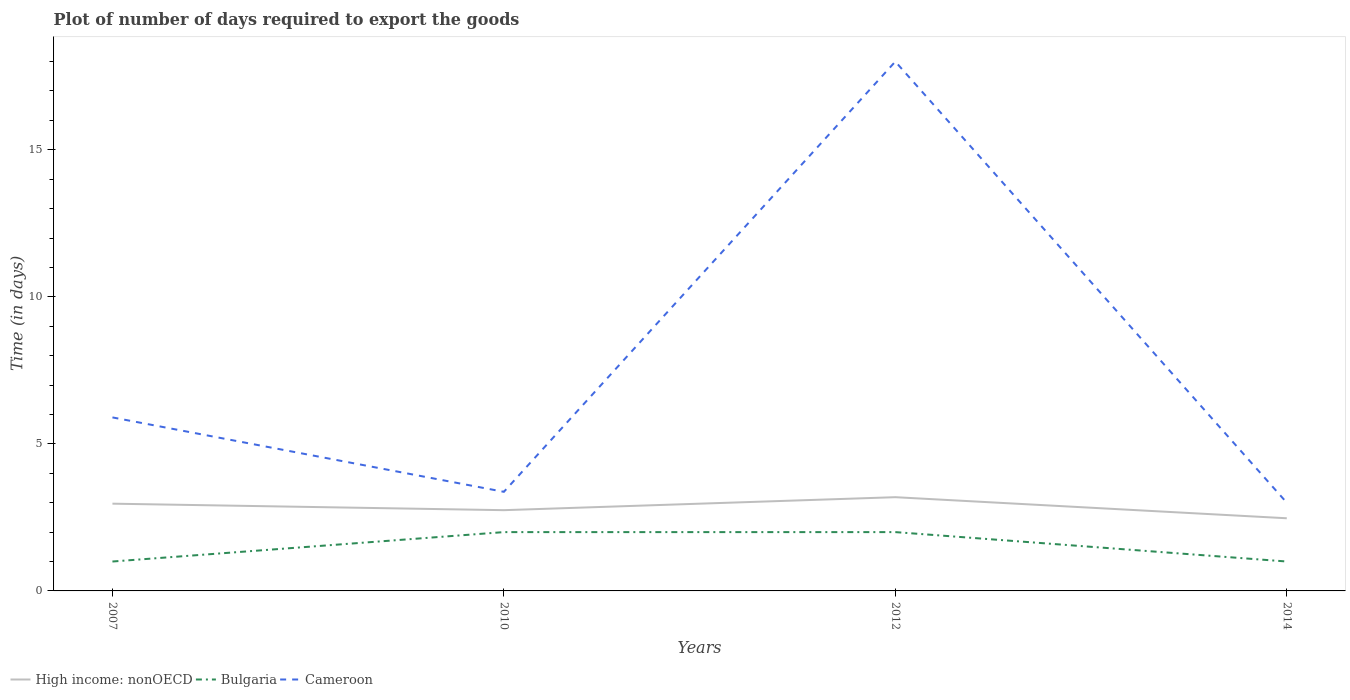How many different coloured lines are there?
Provide a succinct answer. 3. Does the line corresponding to Cameroon intersect with the line corresponding to Bulgaria?
Provide a succinct answer. No. Is the number of lines equal to the number of legend labels?
Give a very brief answer. Yes. In which year was the time required to export goods in Cameroon maximum?
Your response must be concise. 2014. What is the total time required to export goods in High income: nonOECD in the graph?
Give a very brief answer. -0.44. What is the difference between the highest and the second highest time required to export goods in Bulgaria?
Offer a terse response. 1. What is the difference between the highest and the lowest time required to export goods in High income: nonOECD?
Your response must be concise. 2. Is the time required to export goods in High income: nonOECD strictly greater than the time required to export goods in Cameroon over the years?
Provide a succinct answer. Yes. Are the values on the major ticks of Y-axis written in scientific E-notation?
Your answer should be very brief. No. Where does the legend appear in the graph?
Give a very brief answer. Bottom left. What is the title of the graph?
Provide a short and direct response. Plot of number of days required to export the goods. What is the label or title of the Y-axis?
Keep it short and to the point. Time (in days). What is the Time (in days) in High income: nonOECD in 2007?
Make the answer very short. 2.97. What is the Time (in days) of High income: nonOECD in 2010?
Your answer should be very brief. 2.75. What is the Time (in days) of Cameroon in 2010?
Give a very brief answer. 3.37. What is the Time (in days) in High income: nonOECD in 2012?
Give a very brief answer. 3.19. What is the Time (in days) of Bulgaria in 2012?
Give a very brief answer. 2. What is the Time (in days) of Cameroon in 2012?
Keep it short and to the point. 18. What is the Time (in days) in High income: nonOECD in 2014?
Keep it short and to the point. 2.47. Across all years, what is the maximum Time (in days) of High income: nonOECD?
Provide a short and direct response. 3.19. Across all years, what is the maximum Time (in days) of Bulgaria?
Your answer should be compact. 2. Across all years, what is the maximum Time (in days) in Cameroon?
Offer a very short reply. 18. Across all years, what is the minimum Time (in days) of High income: nonOECD?
Offer a terse response. 2.47. Across all years, what is the minimum Time (in days) of Bulgaria?
Your response must be concise. 1. Across all years, what is the minimum Time (in days) in Cameroon?
Make the answer very short. 3. What is the total Time (in days) in High income: nonOECD in the graph?
Your answer should be very brief. 11.37. What is the total Time (in days) of Bulgaria in the graph?
Your answer should be compact. 6. What is the total Time (in days) in Cameroon in the graph?
Your response must be concise. 30.27. What is the difference between the Time (in days) in High income: nonOECD in 2007 and that in 2010?
Offer a very short reply. 0.22. What is the difference between the Time (in days) of Bulgaria in 2007 and that in 2010?
Your answer should be compact. -1. What is the difference between the Time (in days) of Cameroon in 2007 and that in 2010?
Your answer should be very brief. 2.53. What is the difference between the Time (in days) in High income: nonOECD in 2007 and that in 2012?
Keep it short and to the point. -0.22. What is the difference between the Time (in days) in Bulgaria in 2007 and that in 2012?
Offer a very short reply. -1. What is the difference between the Time (in days) of High income: nonOECD in 2007 and that in 2014?
Provide a short and direct response. 0.5. What is the difference between the Time (in days) in High income: nonOECD in 2010 and that in 2012?
Provide a succinct answer. -0.44. What is the difference between the Time (in days) in Bulgaria in 2010 and that in 2012?
Your answer should be very brief. 0. What is the difference between the Time (in days) of Cameroon in 2010 and that in 2012?
Give a very brief answer. -14.63. What is the difference between the Time (in days) in High income: nonOECD in 2010 and that in 2014?
Provide a short and direct response. 0.28. What is the difference between the Time (in days) of Cameroon in 2010 and that in 2014?
Your answer should be very brief. 0.37. What is the difference between the Time (in days) in High income: nonOECD in 2012 and that in 2014?
Make the answer very short. 0.72. What is the difference between the Time (in days) of Cameroon in 2012 and that in 2014?
Ensure brevity in your answer.  15. What is the difference between the Time (in days) of High income: nonOECD in 2007 and the Time (in days) of Bulgaria in 2010?
Make the answer very short. 0.97. What is the difference between the Time (in days) in High income: nonOECD in 2007 and the Time (in days) in Cameroon in 2010?
Provide a short and direct response. -0.4. What is the difference between the Time (in days) of Bulgaria in 2007 and the Time (in days) of Cameroon in 2010?
Make the answer very short. -2.37. What is the difference between the Time (in days) in High income: nonOECD in 2007 and the Time (in days) in Bulgaria in 2012?
Offer a very short reply. 0.97. What is the difference between the Time (in days) of High income: nonOECD in 2007 and the Time (in days) of Cameroon in 2012?
Make the answer very short. -15.03. What is the difference between the Time (in days) in High income: nonOECD in 2007 and the Time (in days) in Bulgaria in 2014?
Your answer should be compact. 1.97. What is the difference between the Time (in days) of High income: nonOECD in 2007 and the Time (in days) of Cameroon in 2014?
Offer a terse response. -0.03. What is the difference between the Time (in days) in Bulgaria in 2007 and the Time (in days) in Cameroon in 2014?
Your answer should be very brief. -2. What is the difference between the Time (in days) of High income: nonOECD in 2010 and the Time (in days) of Bulgaria in 2012?
Keep it short and to the point. 0.75. What is the difference between the Time (in days) of High income: nonOECD in 2010 and the Time (in days) of Cameroon in 2012?
Keep it short and to the point. -15.25. What is the difference between the Time (in days) in High income: nonOECD in 2010 and the Time (in days) in Bulgaria in 2014?
Keep it short and to the point. 1.75. What is the difference between the Time (in days) in High income: nonOECD in 2010 and the Time (in days) in Cameroon in 2014?
Make the answer very short. -0.25. What is the difference between the Time (in days) of Bulgaria in 2010 and the Time (in days) of Cameroon in 2014?
Provide a succinct answer. -1. What is the difference between the Time (in days) in High income: nonOECD in 2012 and the Time (in days) in Bulgaria in 2014?
Provide a succinct answer. 2.19. What is the difference between the Time (in days) of High income: nonOECD in 2012 and the Time (in days) of Cameroon in 2014?
Offer a terse response. 0.19. What is the difference between the Time (in days) of Bulgaria in 2012 and the Time (in days) of Cameroon in 2014?
Your response must be concise. -1. What is the average Time (in days) of High income: nonOECD per year?
Your response must be concise. 2.84. What is the average Time (in days) of Bulgaria per year?
Your answer should be compact. 1.5. What is the average Time (in days) of Cameroon per year?
Provide a succinct answer. 7.57. In the year 2007, what is the difference between the Time (in days) of High income: nonOECD and Time (in days) of Bulgaria?
Ensure brevity in your answer.  1.97. In the year 2007, what is the difference between the Time (in days) of High income: nonOECD and Time (in days) of Cameroon?
Your answer should be compact. -2.93. In the year 2010, what is the difference between the Time (in days) in High income: nonOECD and Time (in days) in Bulgaria?
Your answer should be very brief. 0.75. In the year 2010, what is the difference between the Time (in days) of High income: nonOECD and Time (in days) of Cameroon?
Keep it short and to the point. -0.62. In the year 2010, what is the difference between the Time (in days) in Bulgaria and Time (in days) in Cameroon?
Your answer should be compact. -1.37. In the year 2012, what is the difference between the Time (in days) in High income: nonOECD and Time (in days) in Bulgaria?
Keep it short and to the point. 1.19. In the year 2012, what is the difference between the Time (in days) in High income: nonOECD and Time (in days) in Cameroon?
Make the answer very short. -14.81. In the year 2012, what is the difference between the Time (in days) in Bulgaria and Time (in days) in Cameroon?
Your answer should be very brief. -16. In the year 2014, what is the difference between the Time (in days) in High income: nonOECD and Time (in days) in Bulgaria?
Provide a succinct answer. 1.47. In the year 2014, what is the difference between the Time (in days) of High income: nonOECD and Time (in days) of Cameroon?
Provide a succinct answer. -0.53. What is the ratio of the Time (in days) in High income: nonOECD in 2007 to that in 2010?
Your answer should be compact. 1.08. What is the ratio of the Time (in days) of Bulgaria in 2007 to that in 2010?
Your response must be concise. 0.5. What is the ratio of the Time (in days) of Cameroon in 2007 to that in 2010?
Ensure brevity in your answer.  1.75. What is the ratio of the Time (in days) of High income: nonOECD in 2007 to that in 2012?
Ensure brevity in your answer.  0.93. What is the ratio of the Time (in days) of Cameroon in 2007 to that in 2012?
Keep it short and to the point. 0.33. What is the ratio of the Time (in days) of High income: nonOECD in 2007 to that in 2014?
Offer a very short reply. 1.2. What is the ratio of the Time (in days) of Bulgaria in 2007 to that in 2014?
Provide a succinct answer. 1. What is the ratio of the Time (in days) in Cameroon in 2007 to that in 2014?
Offer a terse response. 1.97. What is the ratio of the Time (in days) of High income: nonOECD in 2010 to that in 2012?
Provide a short and direct response. 0.86. What is the ratio of the Time (in days) of Bulgaria in 2010 to that in 2012?
Provide a succinct answer. 1. What is the ratio of the Time (in days) in Cameroon in 2010 to that in 2012?
Your answer should be very brief. 0.19. What is the ratio of the Time (in days) in High income: nonOECD in 2010 to that in 2014?
Your answer should be compact. 1.11. What is the ratio of the Time (in days) in Bulgaria in 2010 to that in 2014?
Provide a short and direct response. 2. What is the ratio of the Time (in days) of Cameroon in 2010 to that in 2014?
Your answer should be very brief. 1.12. What is the ratio of the Time (in days) of High income: nonOECD in 2012 to that in 2014?
Your response must be concise. 1.29. What is the difference between the highest and the second highest Time (in days) of High income: nonOECD?
Provide a short and direct response. 0.22. What is the difference between the highest and the lowest Time (in days) of High income: nonOECD?
Your response must be concise. 0.72. 